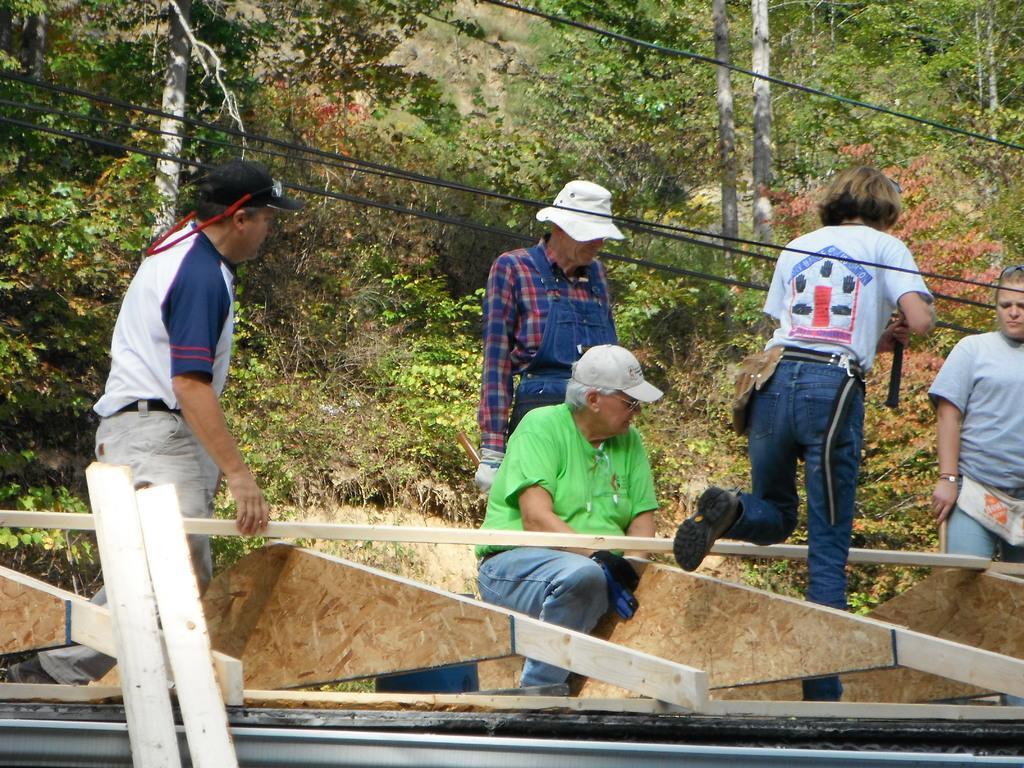Please provide a concise description of this image. In this picture I can see few people are holding wooden fencing, among them one person is sitting on it, behind we can see some trees, plants and grass. 